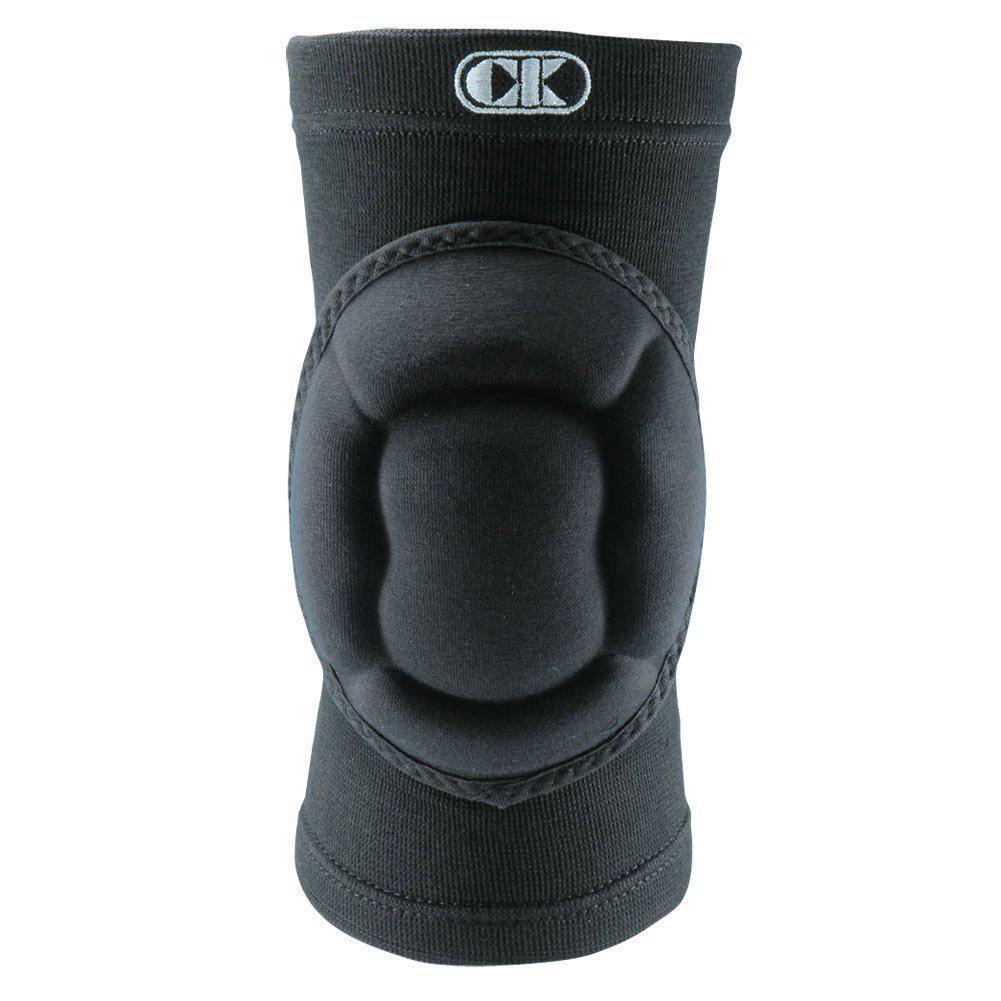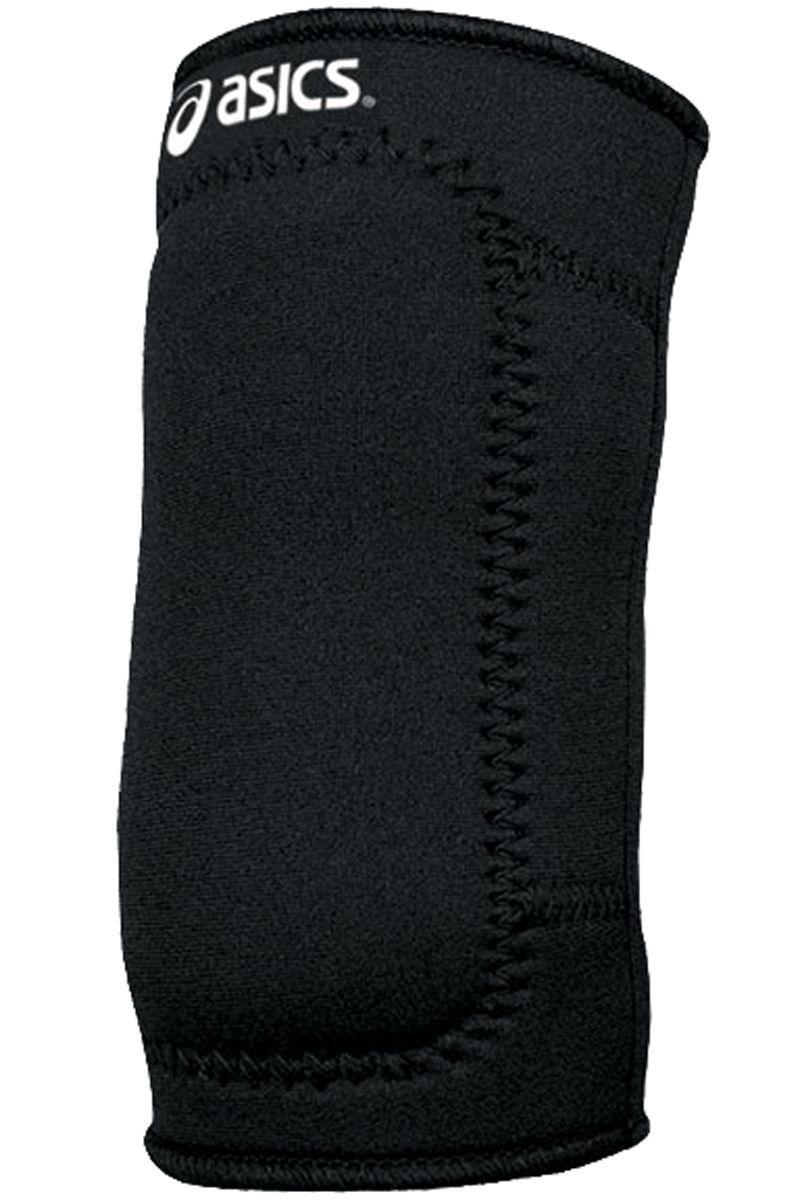The first image is the image on the left, the second image is the image on the right. Examine the images to the left and right. Is the description "Left image features one right-facing kneepad." accurate? Answer yes or no. No. 